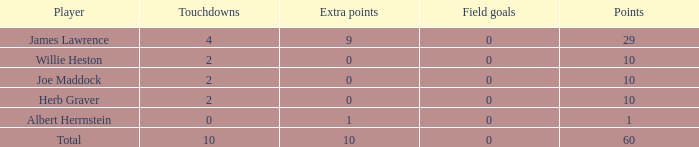Could you help me parse every detail presented in this table? {'header': ['Player', 'Touchdowns', 'Extra points', 'Field goals', 'Points'], 'rows': [['James Lawrence', '4', '9', '0', '29'], ['Willie Heston', '2', '0', '0', '10'], ['Joe Maddock', '2', '0', '0', '10'], ['Herb Graver', '2', '0', '0', '10'], ['Albert Herrnstein', '0', '1', '0', '1'], ['Total', '10', '10', '0', '60']]} What is the smallest number of field goals for players with 4 touchdowns and less than 9 extra points? None. 